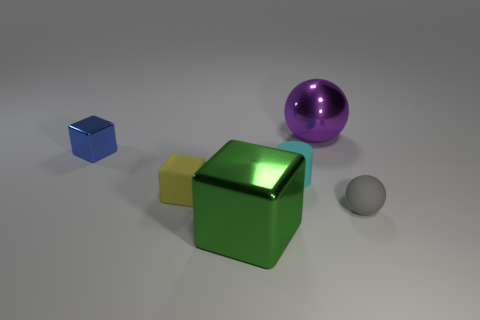Add 2 purple cylinders. How many objects exist? 8 Subtract all spheres. How many objects are left? 4 Subtract 0 purple blocks. How many objects are left? 6 Subtract all tiny cyan cylinders. Subtract all large red metal things. How many objects are left? 5 Add 2 cubes. How many cubes are left? 5 Add 6 tiny rubber cubes. How many tiny rubber cubes exist? 7 